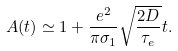Convert formula to latex. <formula><loc_0><loc_0><loc_500><loc_500>A ( t ) \simeq 1 + \frac { e ^ { 2 } } { \pi \sigma _ { 1 } } \sqrt { \frac { 2 D } { \tau _ { e } } } t .</formula> 